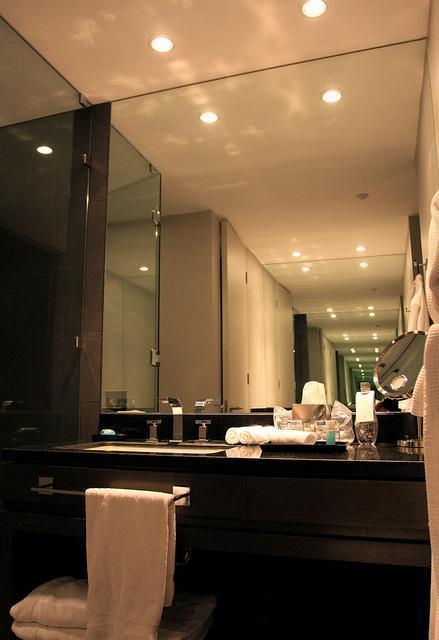How many people are holding tennis rackets?
Give a very brief answer. 0. 